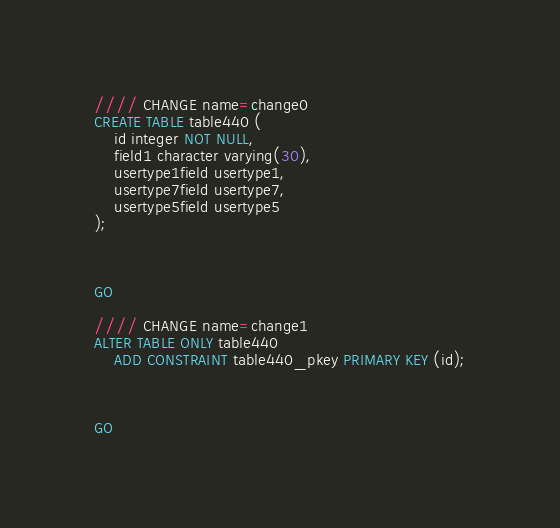<code> <loc_0><loc_0><loc_500><loc_500><_SQL_>//// CHANGE name=change0
CREATE TABLE table440 (
    id integer NOT NULL,
    field1 character varying(30),
    usertype1field usertype1,
    usertype7field usertype7,
    usertype5field usertype5
);



GO

//// CHANGE name=change1
ALTER TABLE ONLY table440
    ADD CONSTRAINT table440_pkey PRIMARY KEY (id);



GO
</code> 